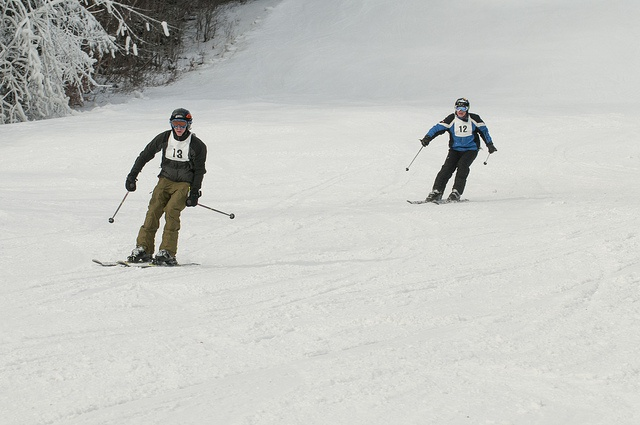Describe the objects in this image and their specific colors. I can see people in gray, black, darkgreen, and lightgray tones, people in gray, black, lightgray, and blue tones, skis in gray, darkgray, lightgray, and beige tones, and skis in gray, darkgray, and lightgray tones in this image. 